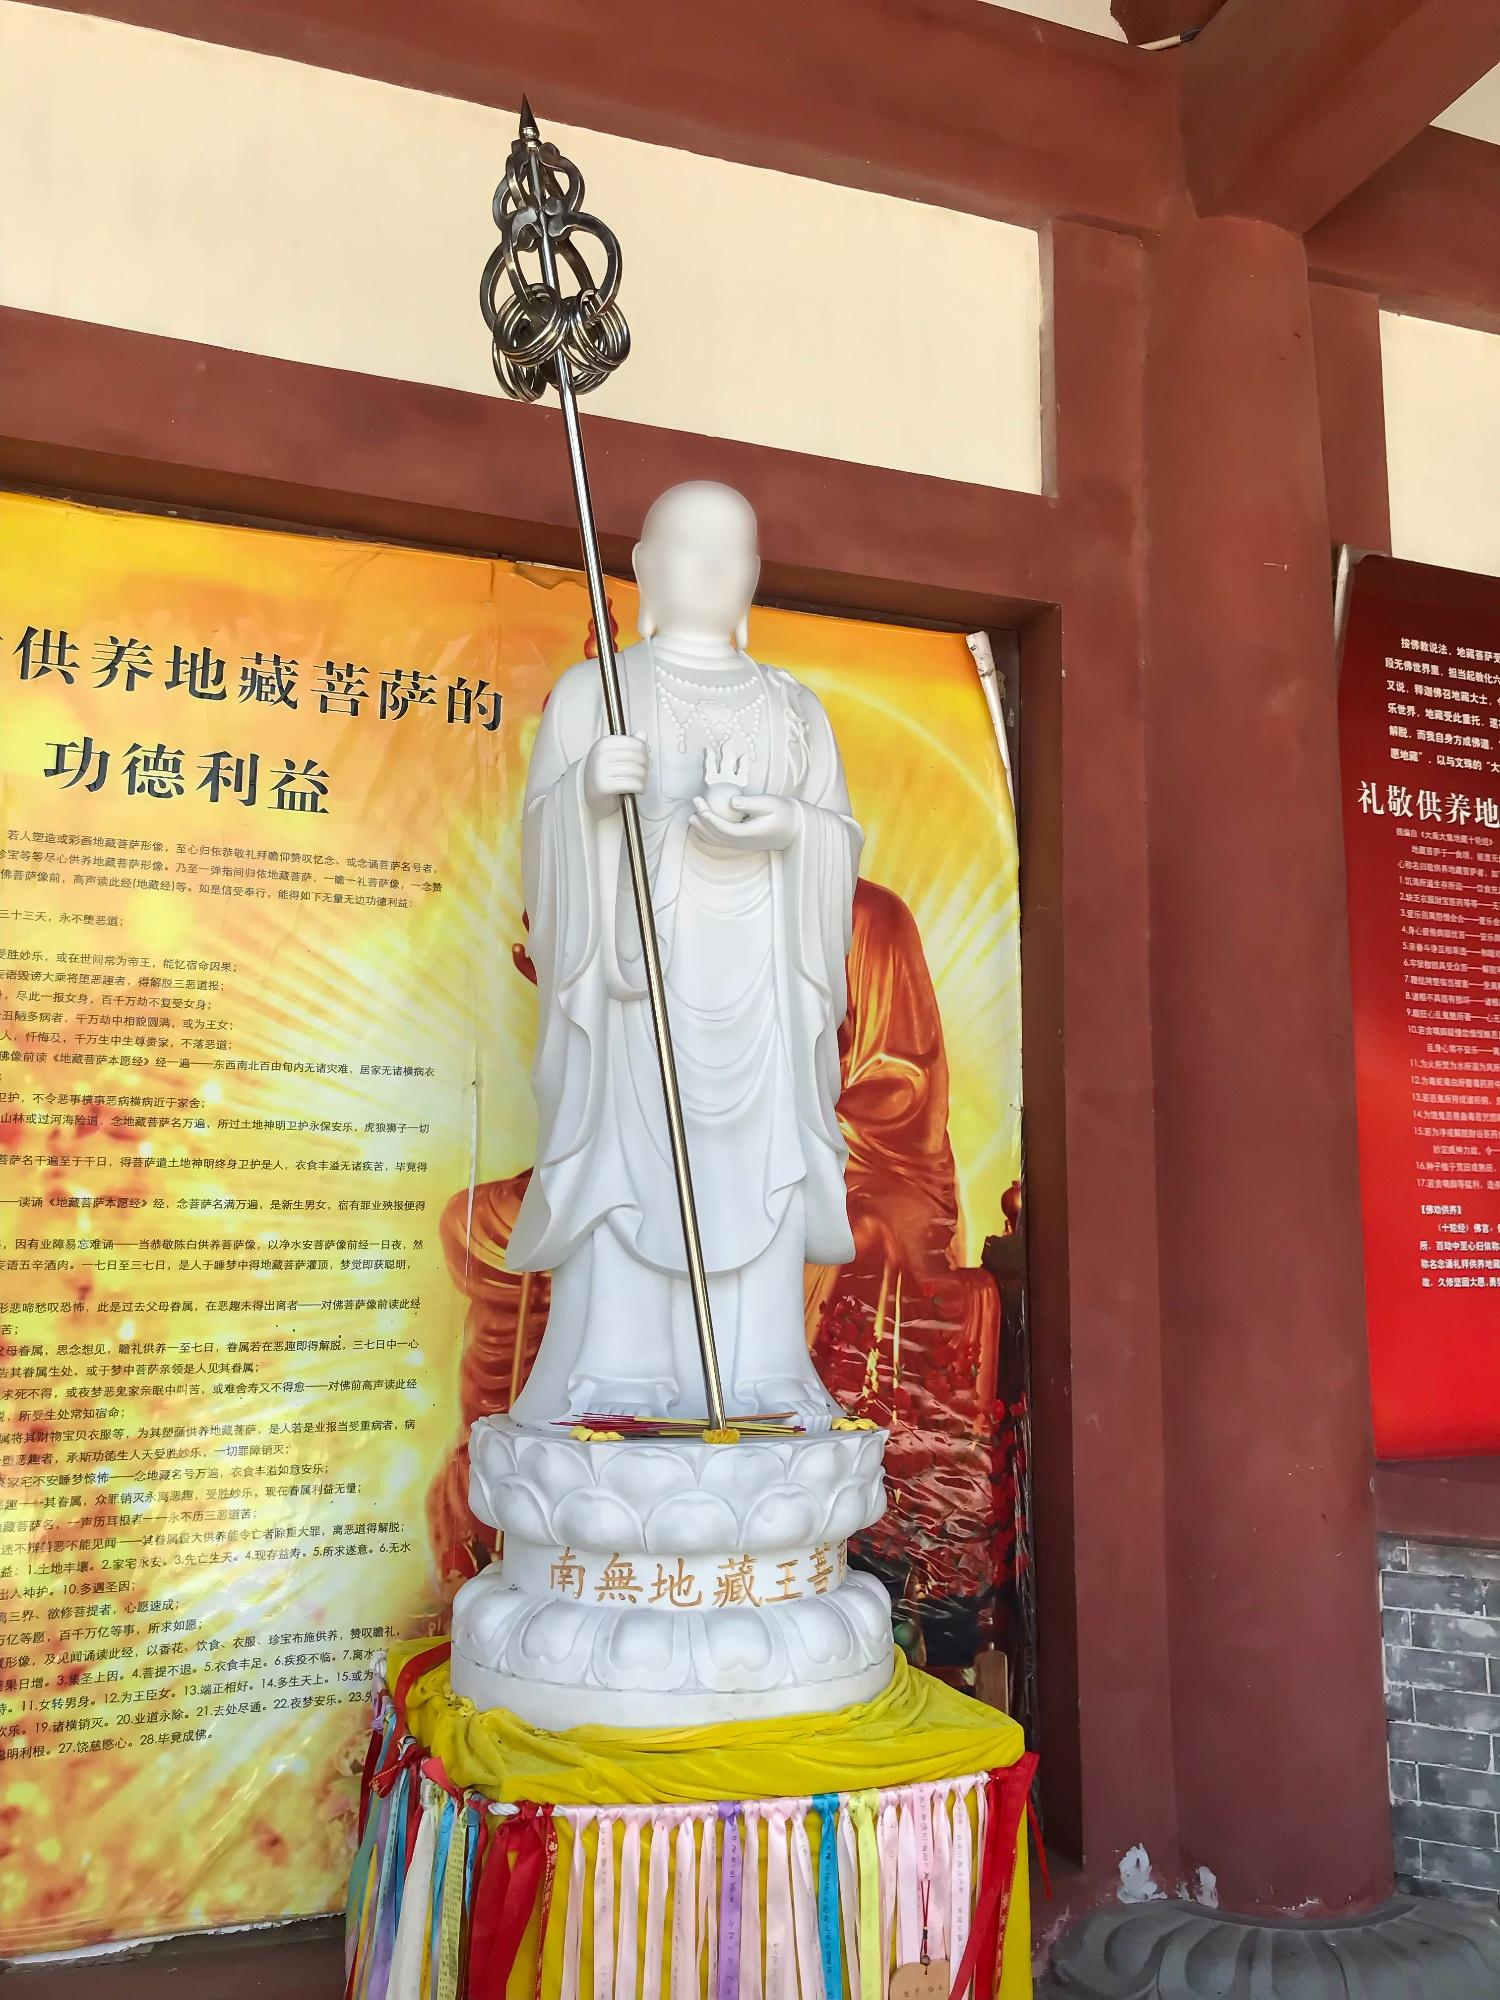What is the significance of the different colors surrounding the statue? The vivid colors of the fabric around the base of the statue typically represent the Five Traditional Chinese Elements. Each color may symbolize a different element and aspect of nature or life, contributing to the balance and harmony within the practice of Buddhism. These colors can make the environment more captivating and could play a role in religious or cultural ceremonies. 